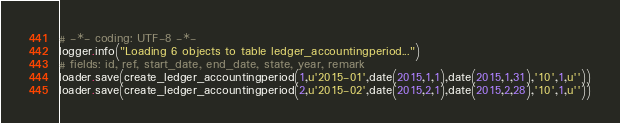Convert code to text. <code><loc_0><loc_0><loc_500><loc_500><_Python_># -*- coding: UTF-8 -*-
logger.info("Loading 6 objects to table ledger_accountingperiod...")
# fields: id, ref, start_date, end_date, state, year, remark
loader.save(create_ledger_accountingperiod(1,u'2015-01',date(2015,1,1),date(2015,1,31),'10',1,u''))
loader.save(create_ledger_accountingperiod(2,u'2015-02',date(2015,2,1),date(2015,2,28),'10',1,u''))</code> 